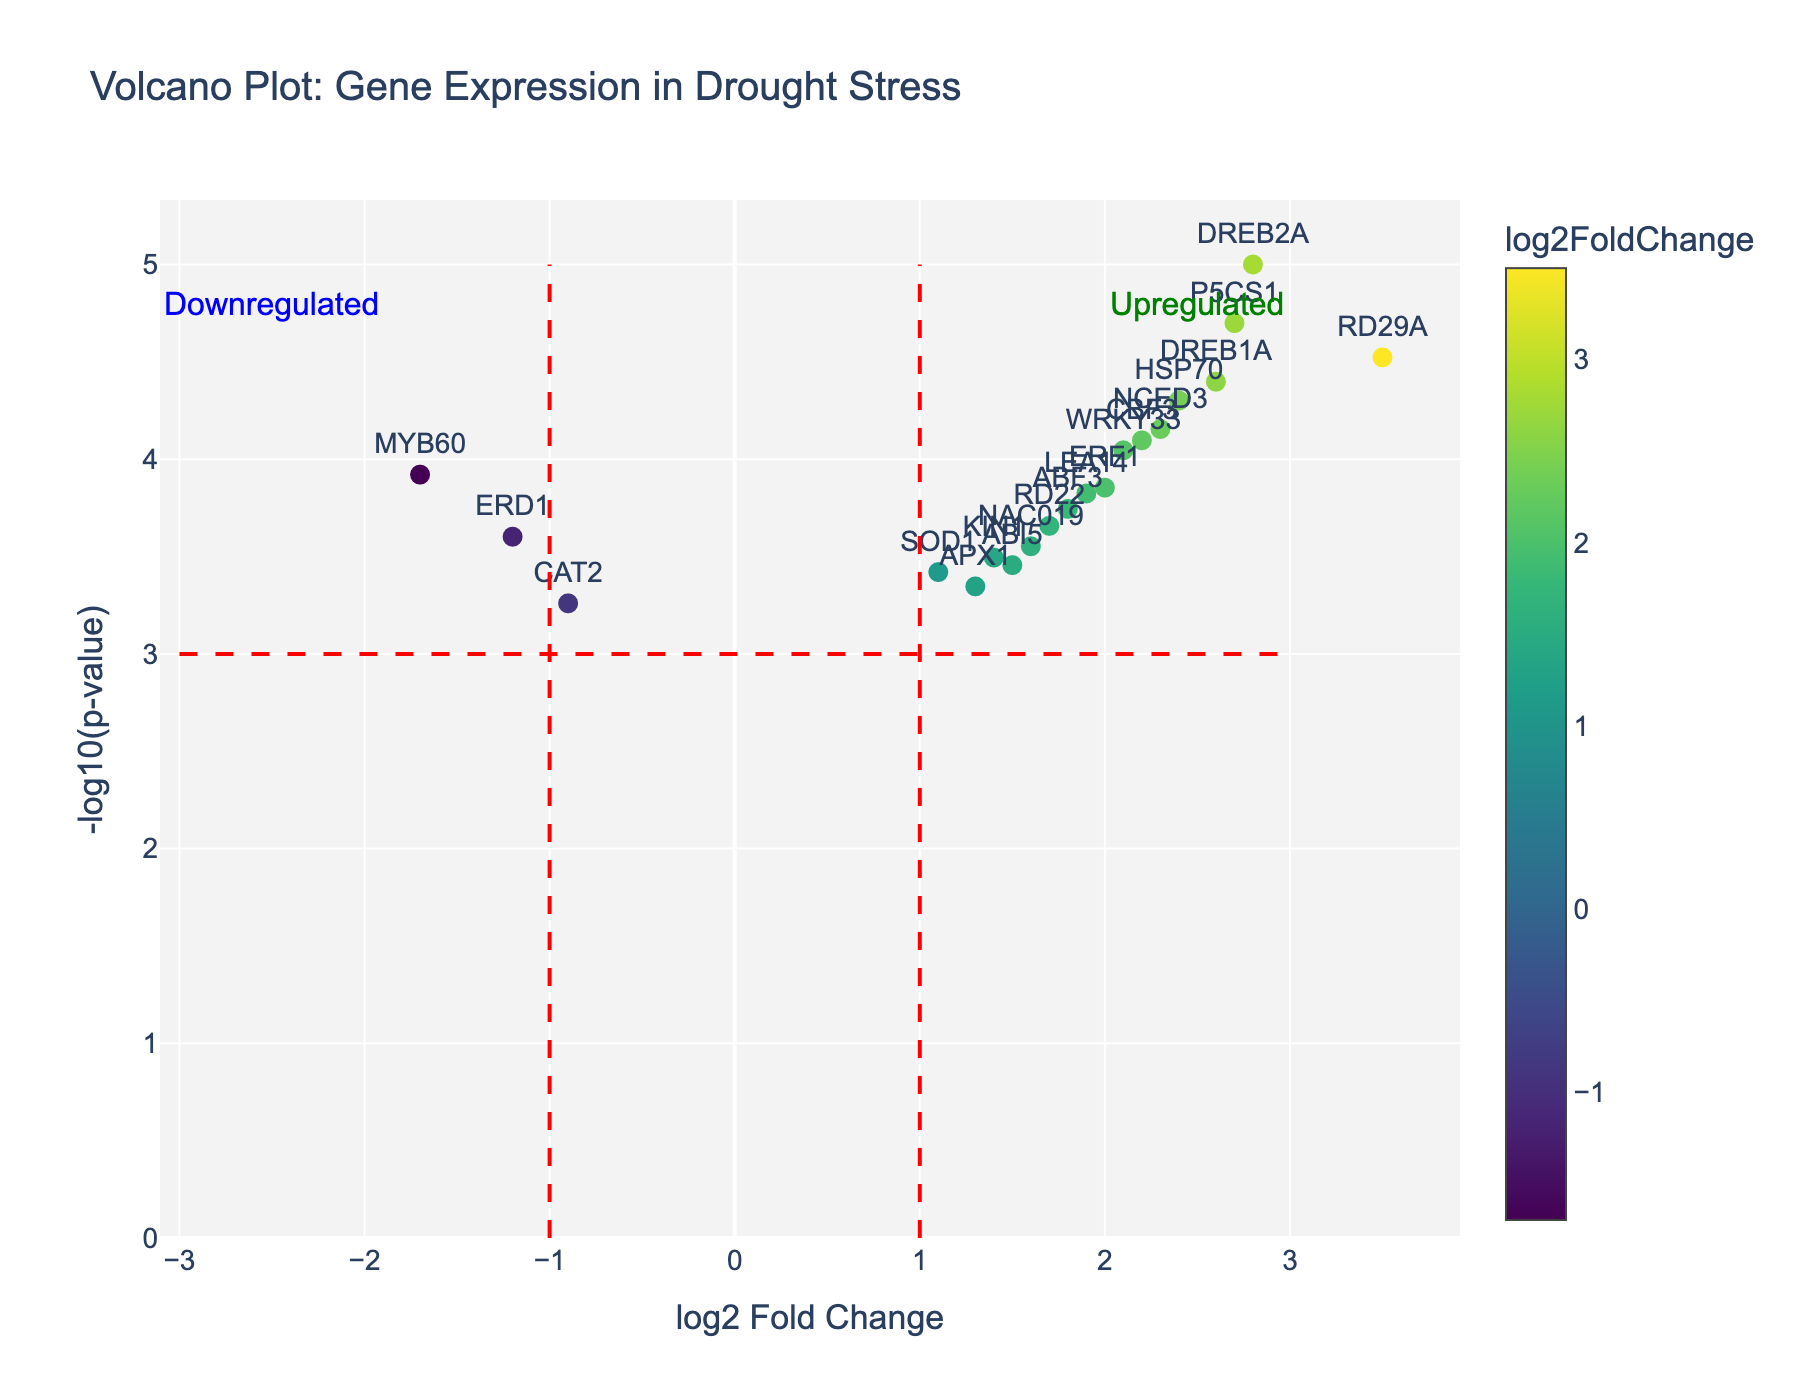What's the title of the plot? The title is displayed at the top of the figure. It summarizes the content of the plot. The title reads "Volcano Plot: Gene Expression in Drought Stress".
Answer: Volcano Plot: Gene Expression in Drought Stress How is the x-axis labeled? The x-axis is labeled with "log2 Fold Change". This indicates that the horizontal axis represents the log2-transformed fold change in gene expression.
Answer: log2 Fold Change How many genes have log2 Fold Change values greater than 2? To find the number of genes with log2 Fold Change values greater than 2, locate the points to the right of the vertical line at 2 on the x-axis. These genes are DREB2A, RD29A, P5CS1, DREB1A, HSP70. Thus, there are 5 genes.
Answer: 5 Which gene shows the highest log2 Fold Change value? Identify the data point furthest to the right. This gene label is RD29A, which indicates that RD29A has the highest log2 Fold Change.
Answer: RD29A What is the log2 Fold Change and -log10(p-value) for MYB60? Locate the point labeled "MYB60". According to the hover text and its position, MYB60 has a log2 Fold Change of -1.7 and a -log10(p-value) of 3.92 (-log10(0.00012)).
Answer: -1.7, 3.92 How many genes are significantly downregulated? Genes are considered significantly downregulated if they are to the left of the vertical line at -1 and above the horizontal line at -log10(p-value) = 3. The only gene in this region is MYB60. Thus, 1 gene is significantly downregulated.
Answer: 1 Which gene is represented by the data point closest to the x-axis and y-axis intersection? The intersection of the axes is at (0,0). The point closest to this is CAT2 with coordinates (-0.9, -log10(0.00055)) or approximately (-0.9, 3.26).
Answer: CAT2 Compare the fold changes of WRKY33 and ERF1. Which one is higher? Locate the points WRKY33 and ERF1 on the plot. WRKY33 has a log2 Fold Change of 2.1, while ERF1 has a log2 Fold Change of 2.0. Therefore, WRKY33 has a higher log2 Fold Change.
Answer: WRKY33 What color represents the gene DREB2A in the plot? In the plot, marker colors are determined by the log2 Fold Change value. DREB2A, with a log2 Fold Change of 2.8, is likely represented by a hue within the color scale of 'Viridis', typically a lighter color towards the warmer end of the scale.
Answer: Light (from Viridis palette) How is upregulation indicated in this plot? Upregulation is typically indicated by positive log2 Fold Change values. In the plot, there is a specific annotation on the right side stating "Upregulated," which marks the area where these genes are found.
Answer: Positive log2 Fold Change values 